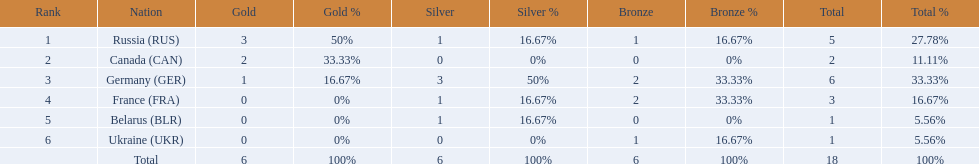Which countries received gold medals? Russia (RUS), Canada (CAN), Germany (GER). Of these countries, which did not receive a silver medal? Canada (CAN). 